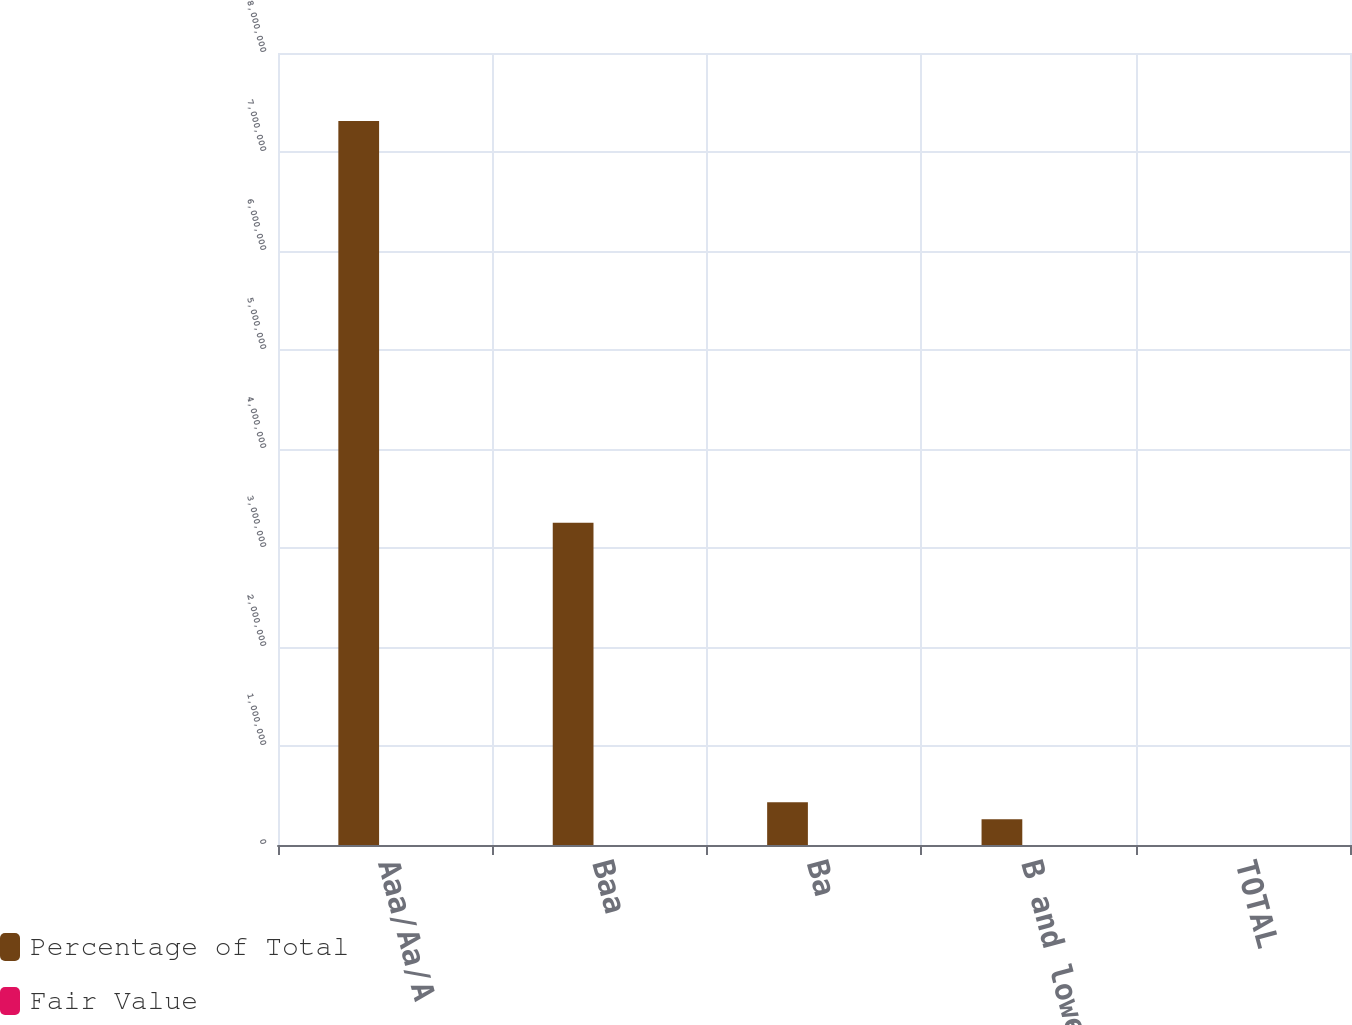Convert chart. <chart><loc_0><loc_0><loc_500><loc_500><stacked_bar_chart><ecel><fcel>Aaa/Aa/A<fcel>Baa<fcel>Ba<fcel>B and lower<fcel>TOTAL<nl><fcel>Percentage of Total<fcel>7.31421e+06<fcel>3.2555e+06<fcel>432203<fcel>261258<fcel>100<nl><fcel>Fair Value<fcel>65<fcel>29<fcel>4<fcel>2<fcel>100<nl></chart> 